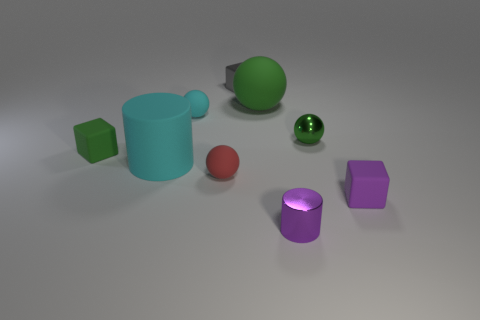Add 1 purple metal cylinders. How many objects exist? 10 Subtract all matte cubes. How many cubes are left? 1 Subtract 2 balls. How many balls are left? 2 Subtract 1 cyan cylinders. How many objects are left? 8 Subtract all cylinders. How many objects are left? 7 Subtract all cyan spheres. Subtract all purple cylinders. How many spheres are left? 3 Subtract all blue spheres. How many gray cylinders are left? 0 Subtract all big cyan cylinders. Subtract all tiny cyan rubber balls. How many objects are left? 7 Add 2 small green rubber things. How many small green rubber things are left? 3 Add 7 big red rubber spheres. How many big red rubber spheres exist? 7 